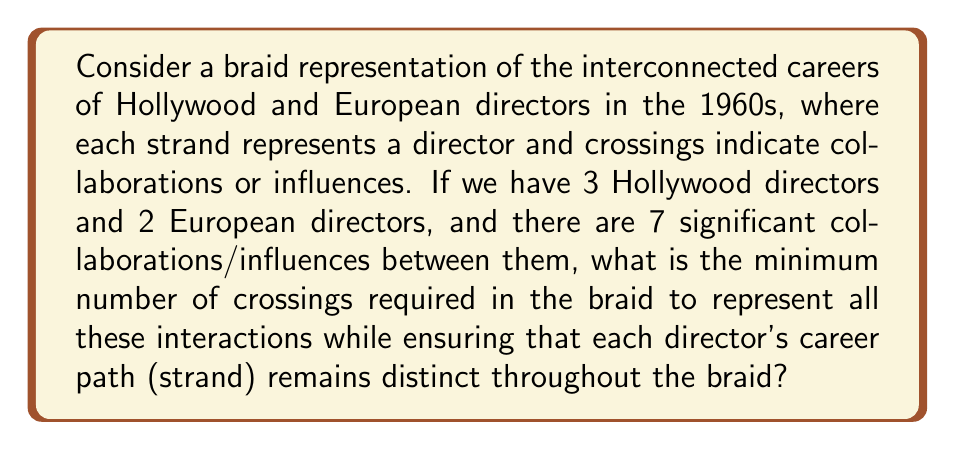Show me your answer to this math problem. To solve this problem, we need to consider the following steps:

1. Understand the braid representation:
   - We have 5 strands in total (3 Hollywood + 2 European directors)
   - Each crossing represents a collaboration/influence
   - We need to maintain distinct strands for each director

2. Consider the minimum number of crossings:
   - With 7 collaborations/influences, we need at least 7 crossings
   - However, we need to ensure that each strand remains distinct

3. Analyze the distinctness requirement:
   - To keep 5 strands distinct, we need at least 4 additional crossings
   - This is because each strand needs to cross at least once with another strand to be distinguishable

4. Calculate the total minimum crossings:
   - Minimum crossings = Collaborations + Distinctness requirement
   - Minimum crossings = 7 + 4 = 11

5. Verify the solution:
   - 11 crossings allow for 7 collaborations/influences
   - 11 crossings also ensure that each of the 5 strands can be distinguished

Therefore, the minimum number of crossings required in the braid representation is 11.
Answer: 11 